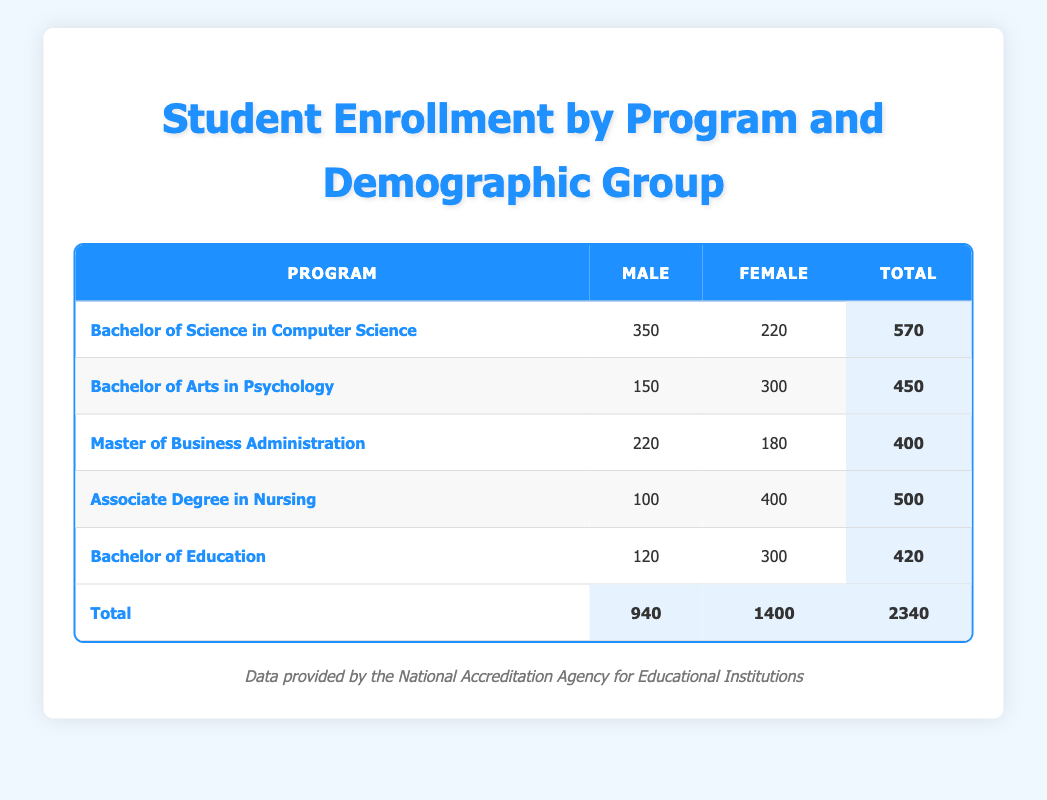What is the total enrollment in the Bachelor of Science in Computer Science program? The total enrollment for this program can be found by adding the male and female enrollments: 350 (male) + 220 (female) = 570.
Answer: 570 Which program has the highest number of female enrollments? By looking at the female enrollments of each program, the Associate Degree in Nursing has 400 female students, which is the highest compared to others.
Answer: Associate Degree in Nursing How many more males are enrolled in the Bachelor of Science in Computer Science than in the Bachelor of Arts in Psychology? The enrollment for males in the Bachelor of Science in Computer Science is 350 and for the Bachelor of Arts in Psychology is 150. The difference is 350 - 150 = 200.
Answer: 200 Is the total enrollment for males greater than the total enrollment for females? The total enrollment for males is 940, and the total for females is 1400. Since 940 is less than 1400, this statement is false.
Answer: No What is the average enrollment per program for female students? There are five programs in total with a cumulative enrollment of 1400 for females. To find the average, we divide 1400 by 5: 1400 / 5 = 280.
Answer: 280 Which demographic group has the lowest total enrollment across all programs? To answer this, we look at the total enrollments: Males have 940 in total, and Females have 1400. Thus, males have the lower total.
Answer: Male What is the combined total enrollment for the Master of Business Administration and Bachelor of Education programs? The total enrollment for the Master of Business Administration is 400 (220 male + 180 female) and for the Bachelor of Education is 420 (120 male + 300 female). The combined total is 400 + 420 = 820.
Answer: 820 How many female students are enrolled in the Bachelor of Arts in Psychology program compared to the total female enrollment? There are 300 female students in the Bachelor of Arts in Psychology program. The total female enrollment across all programs is 1400. The comparison shows that 300 out of 1400 is a specific count, but to answer definitively, it does not exceed the overall total.
Answer: Yes, compared to the total female enrollment, 300 is a part of it 